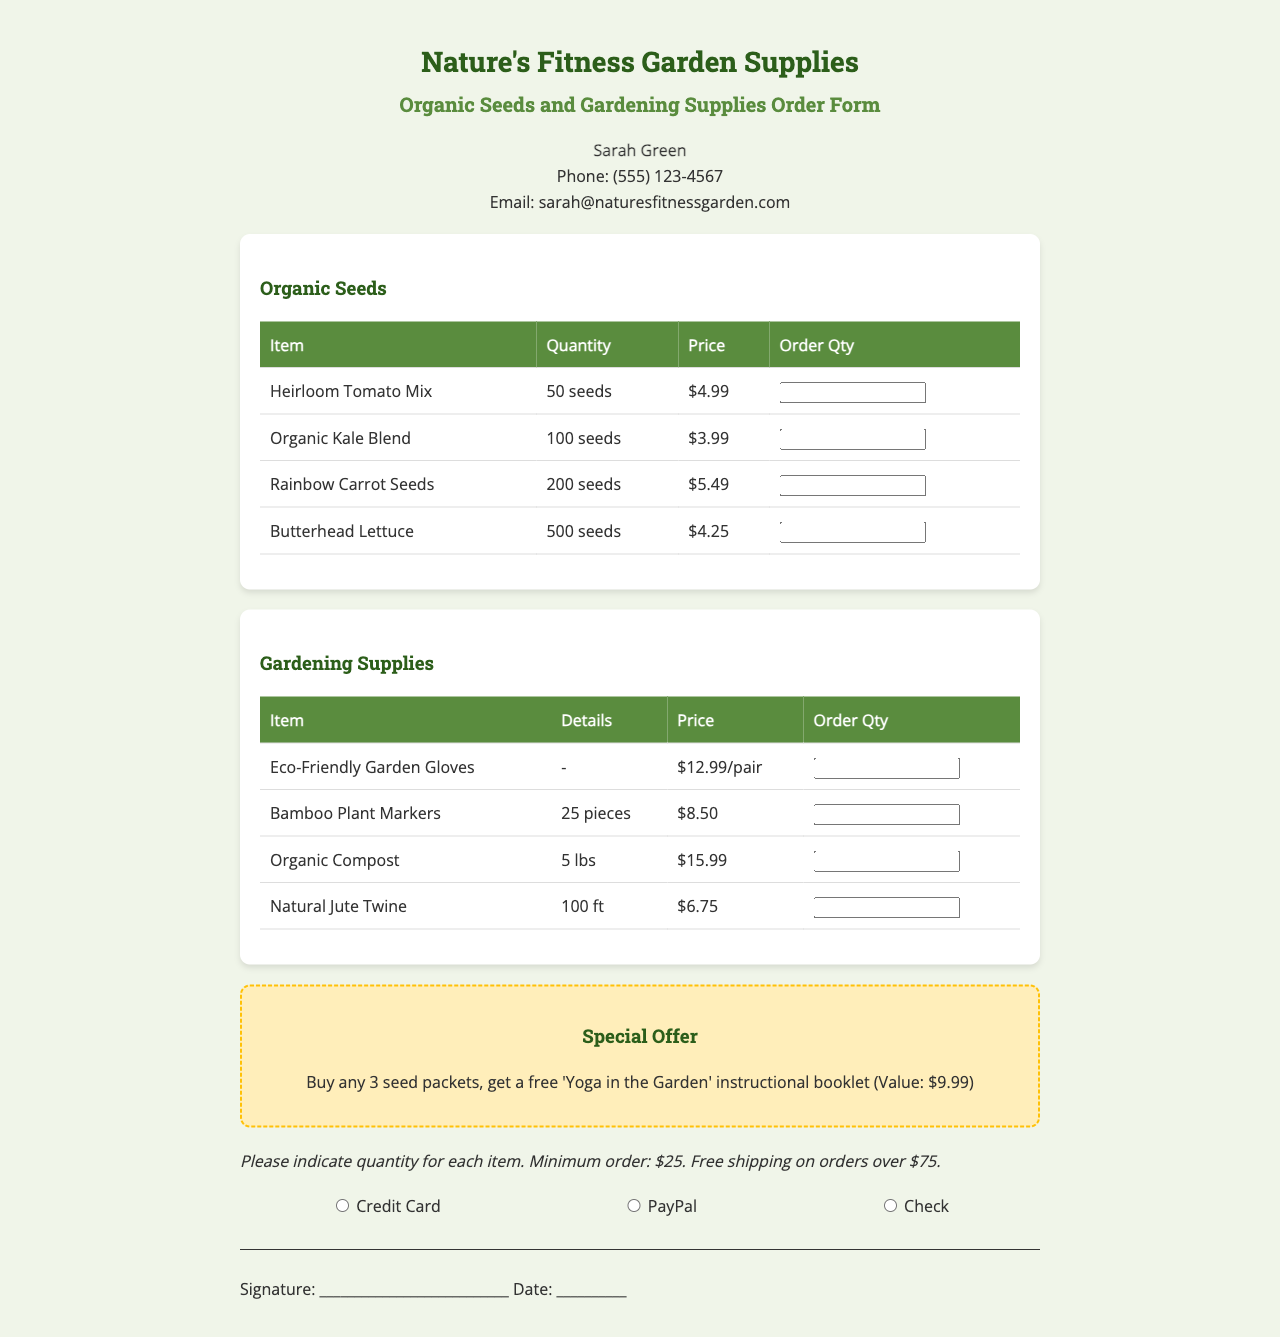What is the name of the person listed for contact? The document provides a specific name for contact, which is Sarah Green.
Answer: Sarah Green What is the price of Organic Kale Blend? The document lists the price of the Organic Kale Blend in the Organic Seeds section as $3.99.
Answer: $3.99 How many seeds are included in the Butterhead Lettuce packet? The document specifies that the Butterhead Lettuce packet contains 500 seeds.
Answer: 500 seeds What is the minimum order amount required? The document mentions that there is a minimum order requirement of $25.
Answer: $25 What special offer is available? The document describes a special offer that includes a free booklet with the purchase of seed packets.
Answer: Buy any 3 seed packets, get a free 'Yoga in the Garden' instructional booklet How many pieces are in a package of Bamboo Plant Markers? The document states that a package of Bamboo Plant Markers contains 25 pieces.
Answer: 25 pieces What shipping condition is mentioned in the document? The document indicates that free shipping is available on orders over $75.
Answer: Free shipping on orders over $75 What is the price of Eco-Friendly Garden Gloves? The document lists the price for Eco-Friendly Garden Gloves as $12.99 per pair.
Answer: $12.99/pair What type of payment options are mentioned? The document specifies the accepted payment methods which include Credit Card, PayPal, and Check.
Answer: Credit Card, PayPal, Check 